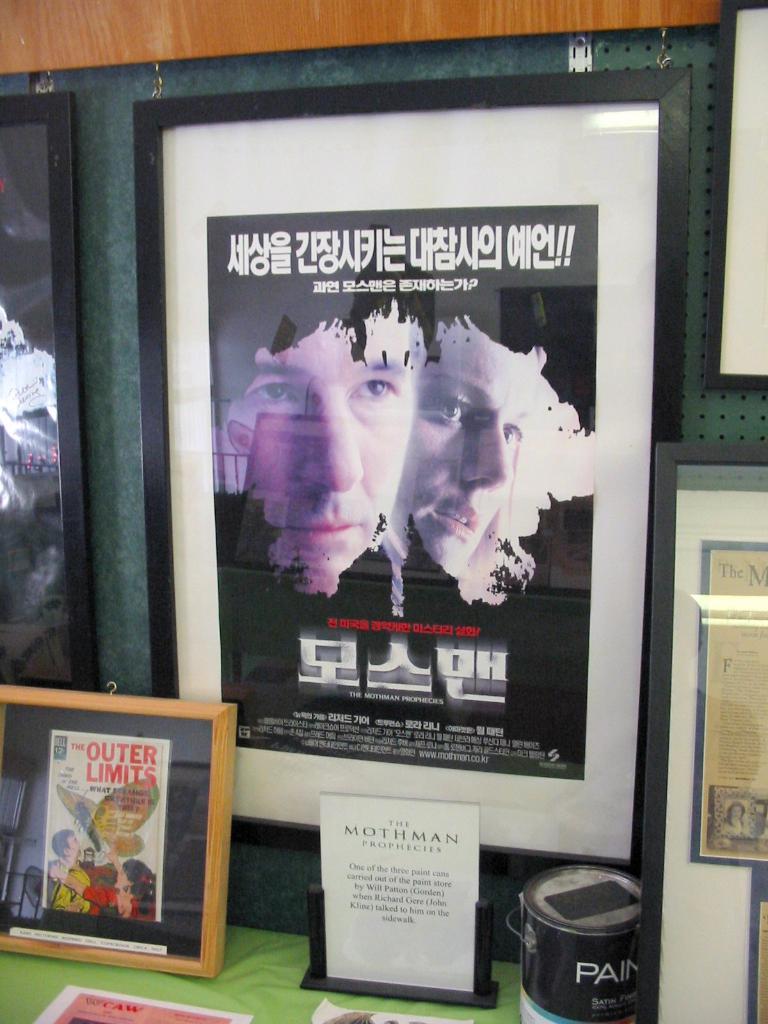What does it say in red on the small poster?
Keep it short and to the point. The outer limits. 